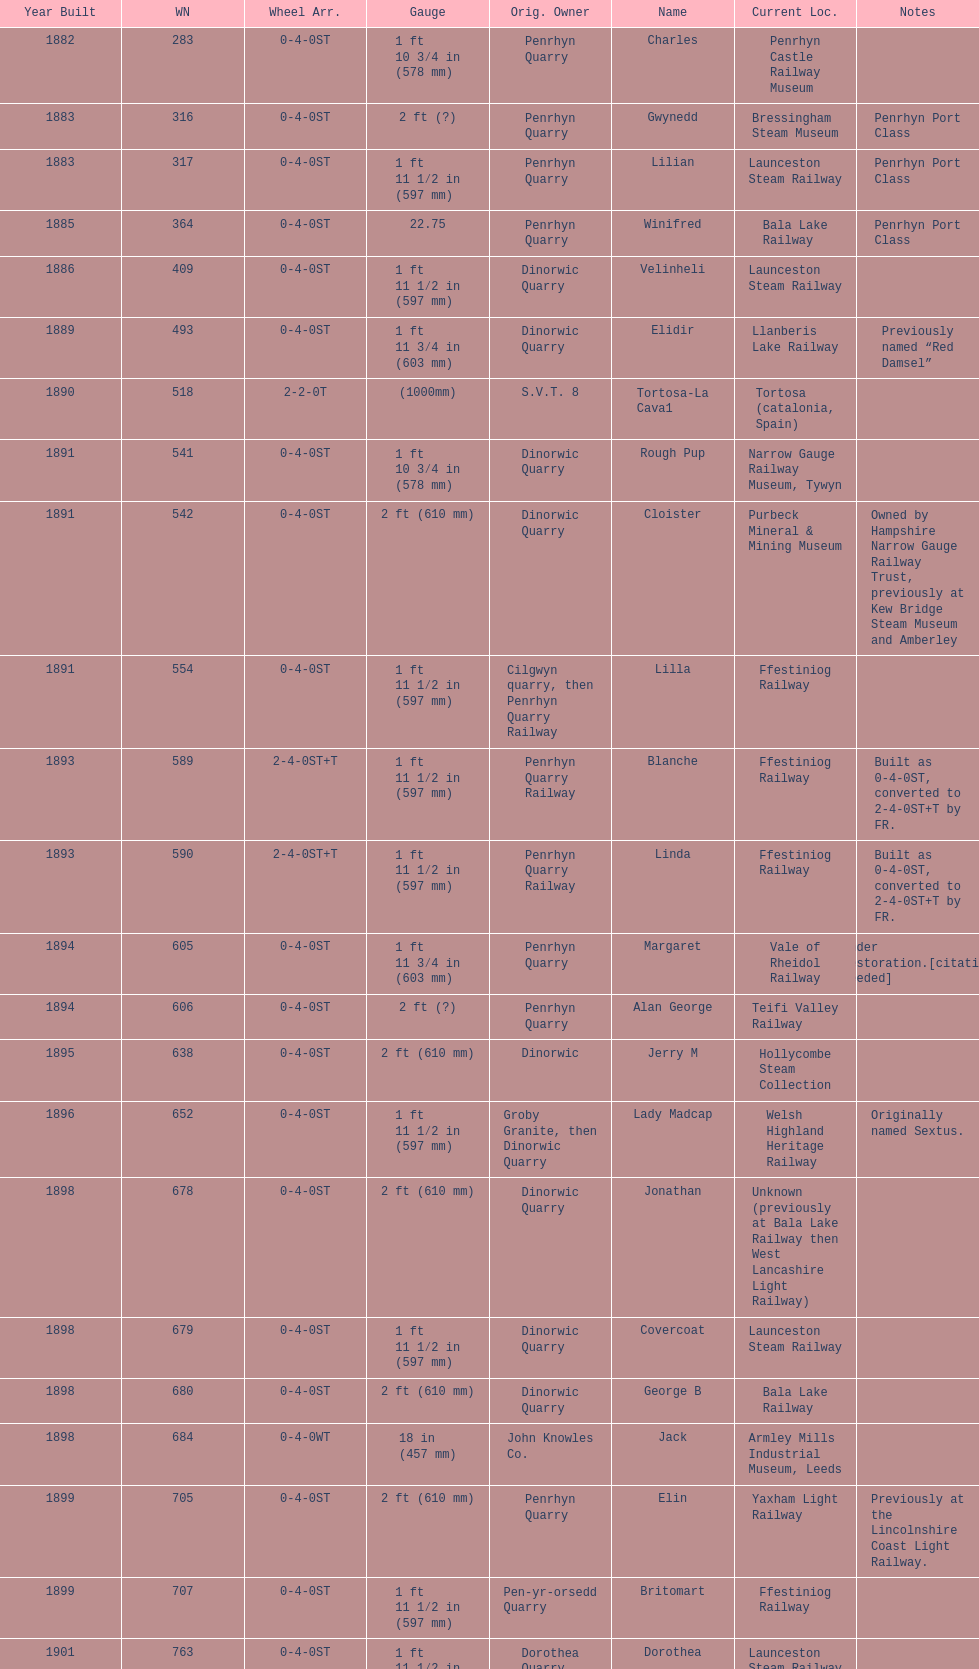What is the total number of preserved hunslet narrow gauge locomotives currently located in ffestiniog railway 554. 